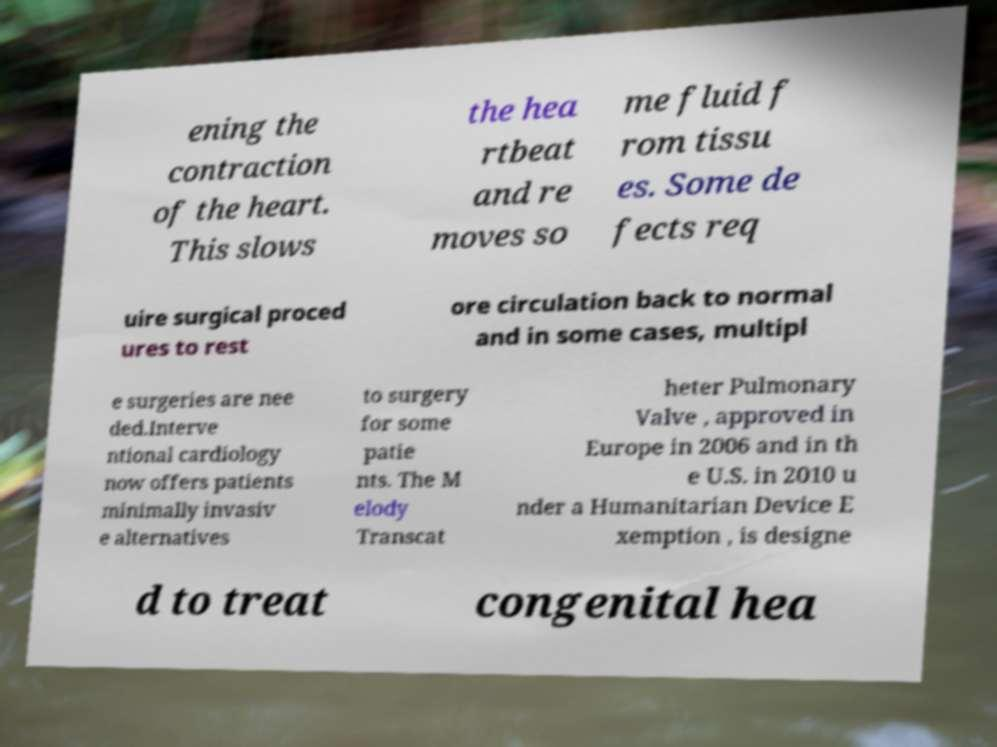Could you assist in decoding the text presented in this image and type it out clearly? ening the contraction of the heart. This slows the hea rtbeat and re moves so me fluid f rom tissu es. Some de fects req uire surgical proced ures to rest ore circulation back to normal and in some cases, multipl e surgeries are nee ded.Interve ntional cardiology now offers patients minimally invasiv e alternatives to surgery for some patie nts. The M elody Transcat heter Pulmonary Valve , approved in Europe in 2006 and in th e U.S. in 2010 u nder a Humanitarian Device E xemption , is designe d to treat congenital hea 